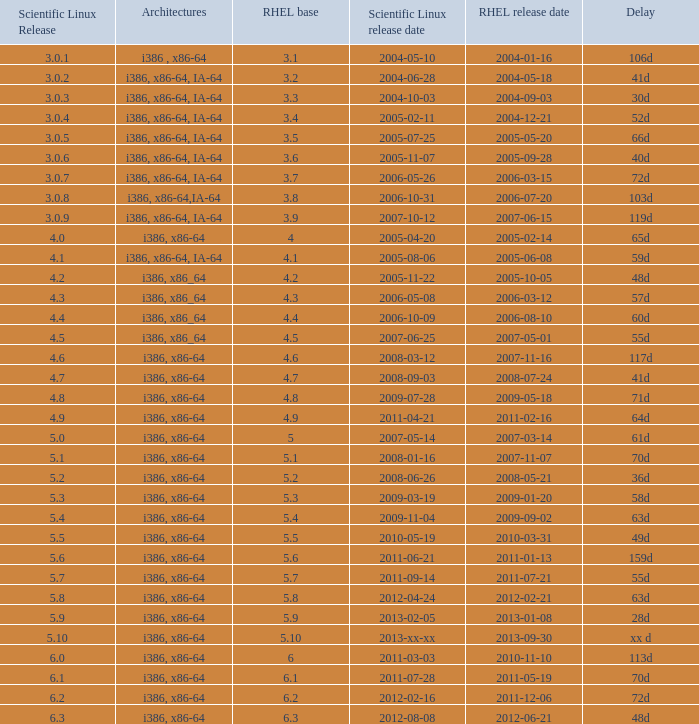Name the scientific linux release when delay is 28d 5.9. 